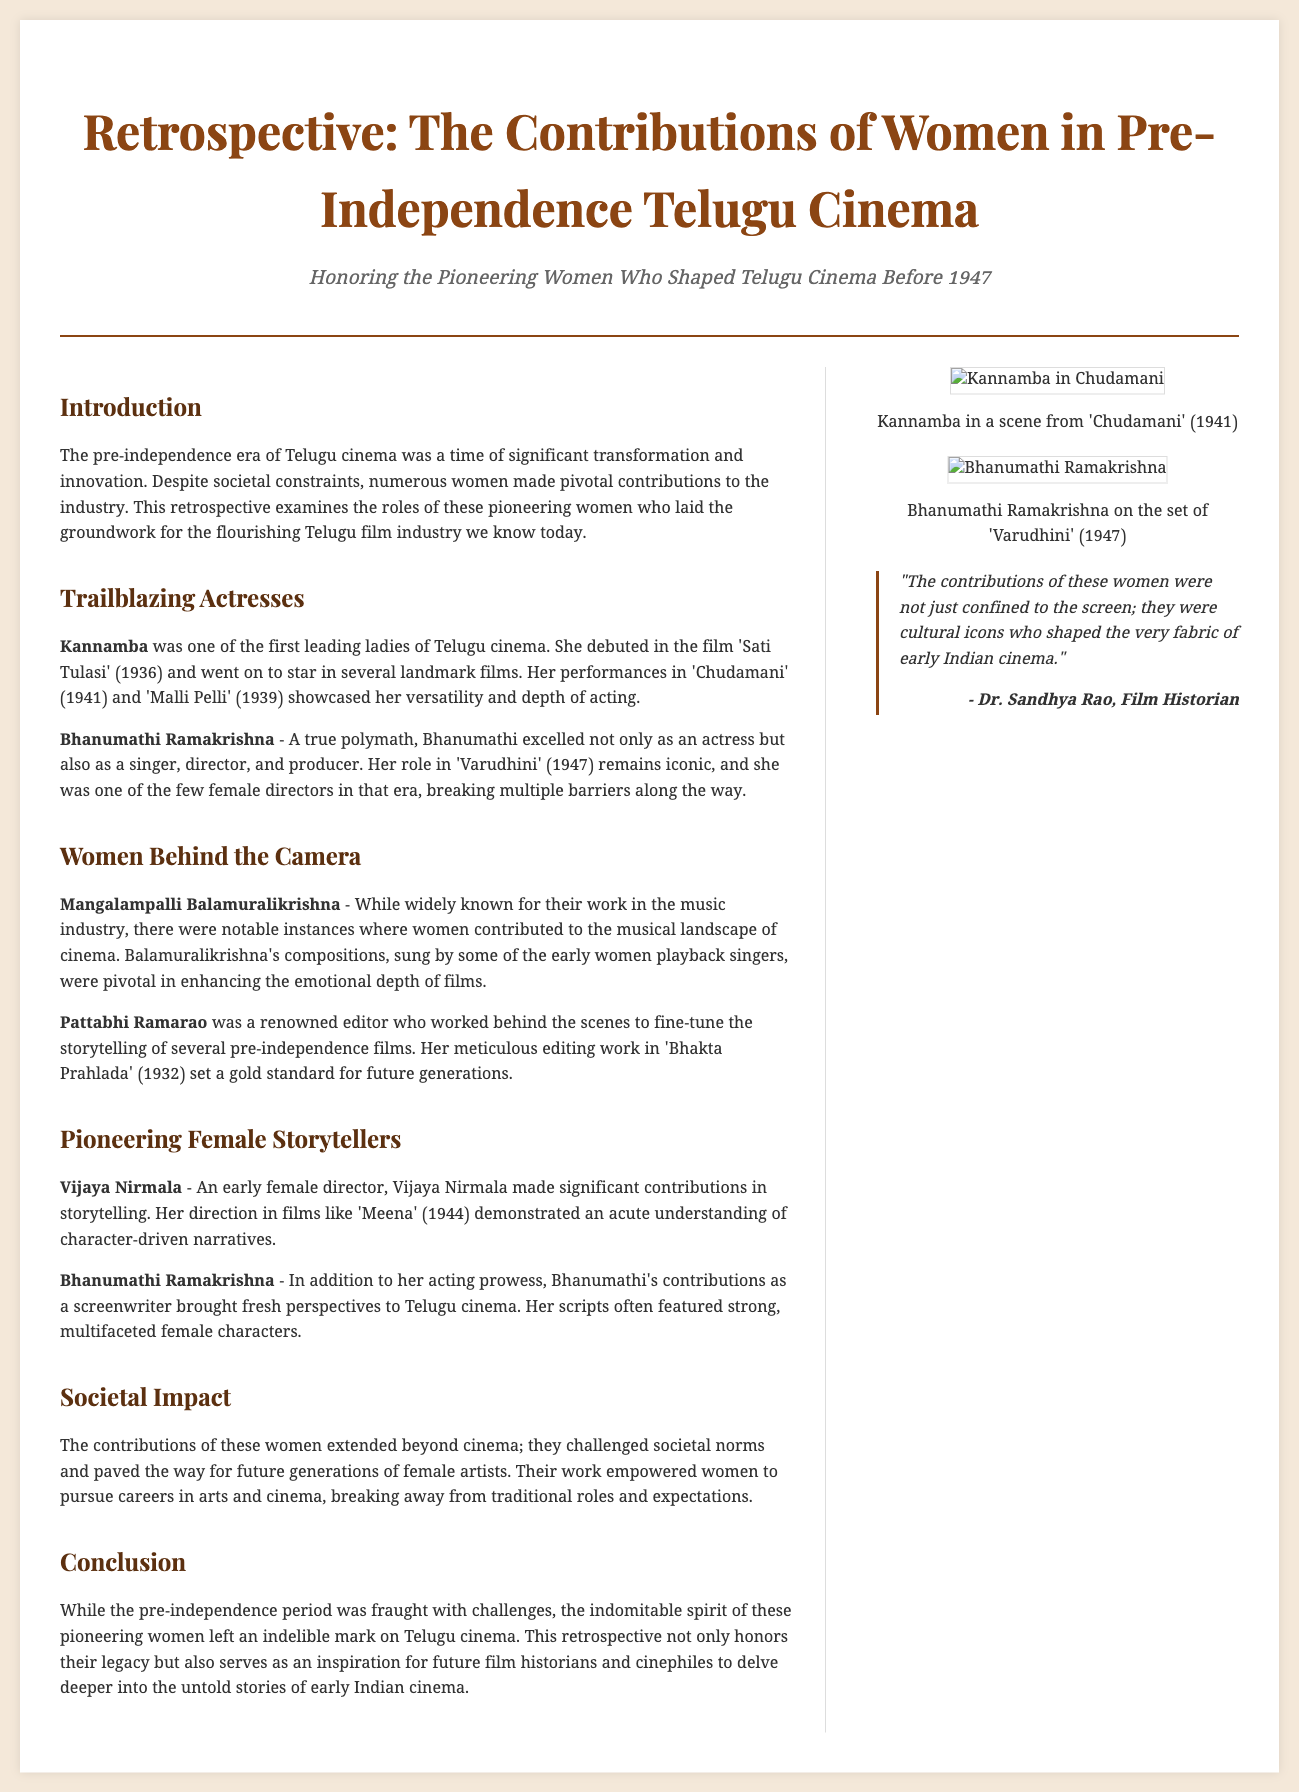what film did Kannamba debut in? The document states that Kannamba debuted in the film 'Sati Tulasi' (1936).
Answer: 'Sati Tulasi' who was one of the first leading ladies of Telugu cinema? The document identifies Kannamba as one of the first leading ladies in Telugu cinema.
Answer: Kannamba which actress is mentioned as a polymath? The document describes Bhanumathi Ramakrishna as a polymath.
Answer: Bhanumathi Ramakrishna what year was 'Bhakta Prahlada' released? The document states that 'Bhakta Prahlada' was released in 1932.
Answer: 1932 who composed music that featured early women playback singers? The document mentions Mangalampalli Balamuralikrishna contributed to the musical landscape of cinema.
Answer: Mangalampalli Balamuralikrishna what role did Bhanumathi Ramakrishna perform in 'Varudhini'? The document notes that Bhanumathi Ramakrishna’s role in 'Varudhini' (1947) remains iconic.
Answer: iconic what type of impact did these women have beyond cinema? The document states that their contributions challenged societal norms and empowered women.
Answer: societal impact who is quoted in the document as a film historian? The document quotes Dr. Sandhya Rao as a film historian.
Answer: Dr. Sandhya Rao what is the main theme of the retrospective? The document suggests that the retrospective honors pioneering women who shaped Telugu cinema before 1947.
Answer: contributions of women 